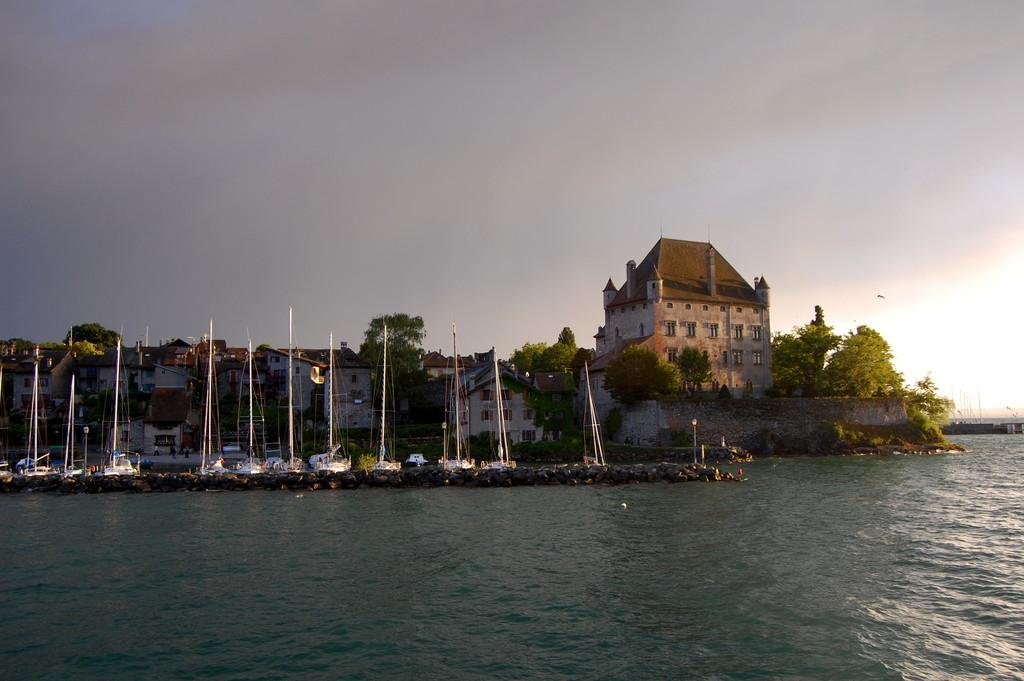What type of vehicles can be seen in the image? There are boats in the image. What is the primary element surrounding the boats? There is water visible in the image. What type of natural features can be seen in the image? There are stones, trees, and plants in the image. What type of structures can be seen in the image? There are buildings and a wall in the image. What part of the natural environment is visible in the image? The sky is visible in the image. How many cows are visible in the image? There are no cows present in the image. What type of net is being used to catch fish in the image? There is no net or fishing activity depicted in the image. 